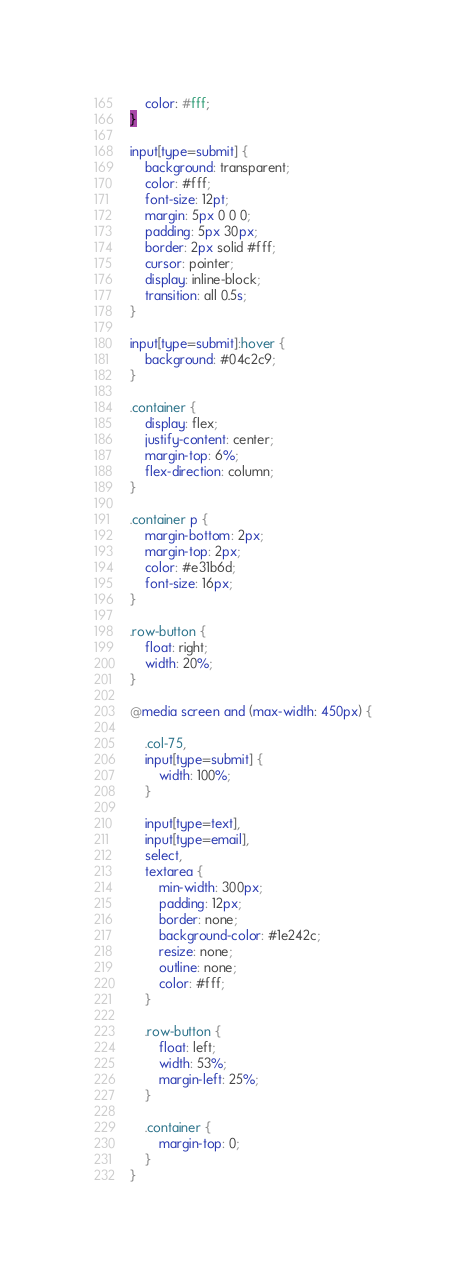Convert code to text. <code><loc_0><loc_0><loc_500><loc_500><_CSS_>    color: #fff;
}

input[type=submit] {
    background: transparent;
    color: #fff;
    font-size: 12pt;
    margin: 5px 0 0 0;
    padding: 5px 30px;
    border: 2px solid #fff;
    cursor: pointer;
    display: inline-block;
    transition: all 0.5s;
}

input[type=submit]:hover {
    background: #04c2c9;
}

.container {
    display: flex;
    justify-content: center;
    margin-top: 6%;
    flex-direction: column;
}

.container p {
    margin-bottom: 2px;
    margin-top: 2px;
    color: #e31b6d;
    font-size: 16px;
}

.row-button {
    float: right;
    width: 20%;
}

@media screen and (max-width: 450px) {

    .col-75,
    input[type=submit] {
        width: 100%;
    }

    input[type=text],
    input[type=email],
    select,
    textarea {
        min-width: 300px;
        padding: 12px;
        border: none;
        background-color: #1e242c;
        resize: none;
        outline: none;
        color: #fff;
    }

    .row-button {
        float: left;
        width: 53%;
        margin-left: 25%;
    }

    .container {
        margin-top: 0;
    }
}
</code> 